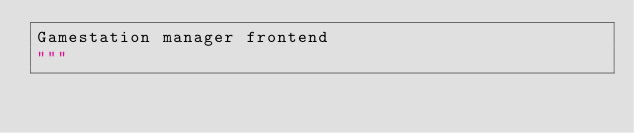Convert code to text. <code><loc_0><loc_0><loc_500><loc_500><_Python_>Gamestation manager frontend
"""</code> 